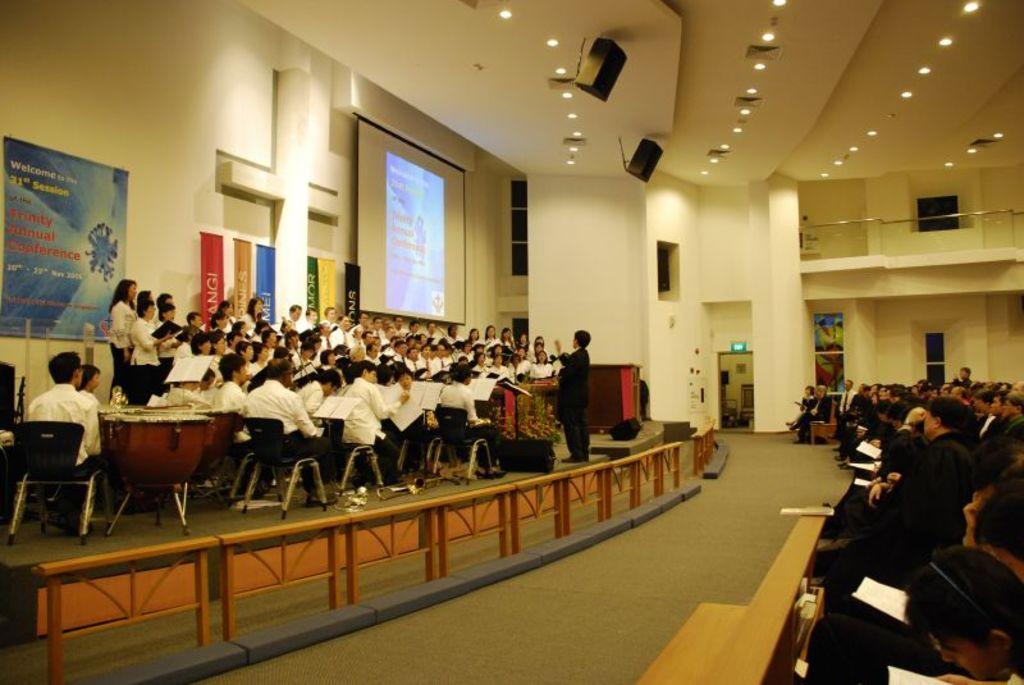Describe this image in one or two sentences. In the image we can see there are people sitting and standing. They are wearing clothes. We can even see there are many chairs, posters and banners. Here we can see the projected screen, floor and sound boxes. Here we can see the lights and the windows. We can even see there are people holding books in their hands. 